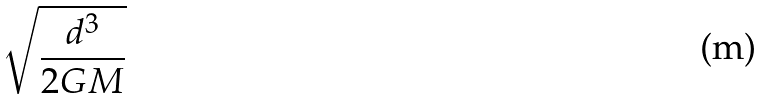<formula> <loc_0><loc_0><loc_500><loc_500>\sqrt { \frac { d ^ { 3 } } { 2 G M } }</formula> 